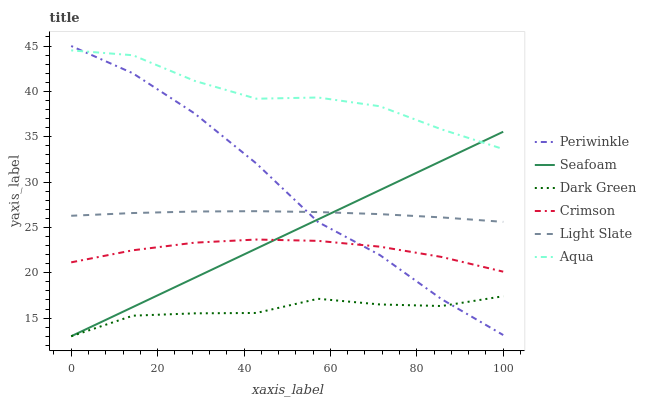Does Dark Green have the minimum area under the curve?
Answer yes or no. Yes. Does Aqua have the maximum area under the curve?
Answer yes or no. Yes. Does Seafoam have the minimum area under the curve?
Answer yes or no. No. Does Seafoam have the maximum area under the curve?
Answer yes or no. No. Is Seafoam the smoothest?
Answer yes or no. Yes. Is Periwinkle the roughest?
Answer yes or no. Yes. Is Aqua the smoothest?
Answer yes or no. No. Is Aqua the roughest?
Answer yes or no. No. Does Aqua have the lowest value?
Answer yes or no. No. Does Periwinkle have the highest value?
Answer yes or no. Yes. Does Aqua have the highest value?
Answer yes or no. No. Is Light Slate less than Aqua?
Answer yes or no. Yes. Is Aqua greater than Light Slate?
Answer yes or no. Yes. Does Light Slate intersect Aqua?
Answer yes or no. No. 